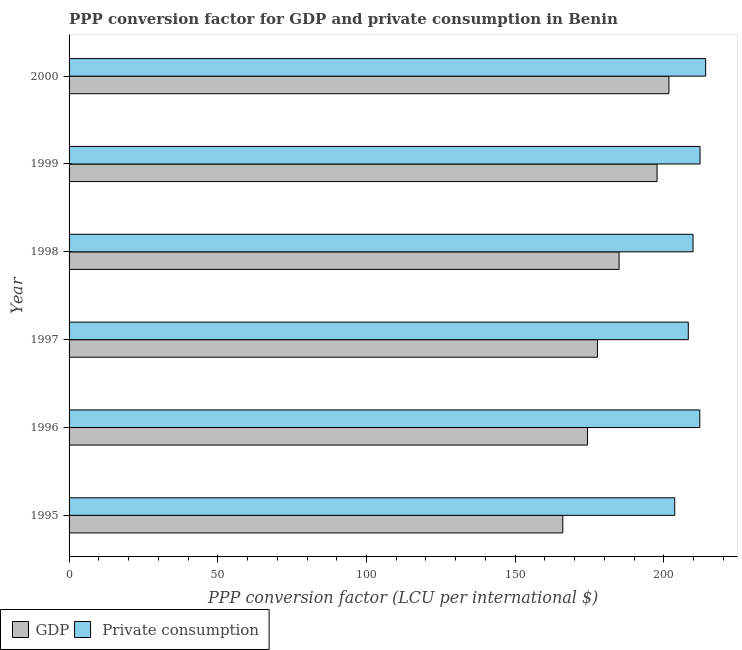How many different coloured bars are there?
Offer a very short reply. 2. Are the number of bars on each tick of the Y-axis equal?
Keep it short and to the point. Yes. How many bars are there on the 3rd tick from the top?
Give a very brief answer. 2. What is the ppp conversion factor for private consumption in 1995?
Provide a succinct answer. 203.64. Across all years, what is the maximum ppp conversion factor for private consumption?
Offer a terse response. 214.04. Across all years, what is the minimum ppp conversion factor for private consumption?
Provide a short and direct response. 203.64. In which year was the ppp conversion factor for gdp minimum?
Offer a terse response. 1995. What is the total ppp conversion factor for gdp in the graph?
Give a very brief answer. 1102.29. What is the difference between the ppp conversion factor for private consumption in 1999 and that in 2000?
Give a very brief answer. -1.89. What is the difference between the ppp conversion factor for private consumption in 1998 and the ppp conversion factor for gdp in 2000?
Offer a very short reply. 8.1. What is the average ppp conversion factor for gdp per year?
Your answer should be very brief. 183.72. In the year 1996, what is the difference between the ppp conversion factor for private consumption and ppp conversion factor for gdp?
Your answer should be very brief. 37.77. What is the ratio of the ppp conversion factor for gdp in 1997 to that in 1999?
Your answer should be compact. 0.9. Is the ppp conversion factor for gdp in 1996 less than that in 1998?
Make the answer very short. Yes. Is the difference between the ppp conversion factor for private consumption in 1997 and 2000 greater than the difference between the ppp conversion factor for gdp in 1997 and 2000?
Provide a short and direct response. Yes. What is the difference between the highest and the second highest ppp conversion factor for gdp?
Offer a terse response. 3.99. What is the difference between the highest and the lowest ppp conversion factor for gdp?
Make the answer very short. 35.68. In how many years, is the ppp conversion factor for gdp greater than the average ppp conversion factor for gdp taken over all years?
Provide a succinct answer. 3. Is the sum of the ppp conversion factor for gdp in 1995 and 1999 greater than the maximum ppp conversion factor for private consumption across all years?
Your answer should be compact. Yes. What does the 1st bar from the top in 1998 represents?
Offer a terse response.  Private consumption. What does the 2nd bar from the bottom in 1998 represents?
Provide a succinct answer.  Private consumption. How many bars are there?
Ensure brevity in your answer.  12. Are the values on the major ticks of X-axis written in scientific E-notation?
Your answer should be very brief. No. Does the graph contain grids?
Make the answer very short. No. Where does the legend appear in the graph?
Provide a short and direct response. Bottom left. What is the title of the graph?
Make the answer very short. PPP conversion factor for GDP and private consumption in Benin. What is the label or title of the X-axis?
Make the answer very short. PPP conversion factor (LCU per international $). What is the PPP conversion factor (LCU per international $) of GDP in 1995?
Offer a very short reply. 166.01. What is the PPP conversion factor (LCU per international $) in  Private consumption in 1995?
Your answer should be very brief. 203.64. What is the PPP conversion factor (LCU per international $) in GDP in 1996?
Your answer should be very brief. 174.29. What is the PPP conversion factor (LCU per international $) in  Private consumption in 1996?
Give a very brief answer. 212.07. What is the PPP conversion factor (LCU per international $) of GDP in 1997?
Your answer should be very brief. 177.65. What is the PPP conversion factor (LCU per international $) in  Private consumption in 1997?
Give a very brief answer. 208.2. What is the PPP conversion factor (LCU per international $) of GDP in 1998?
Your answer should be compact. 184.93. What is the PPP conversion factor (LCU per international $) of  Private consumption in 1998?
Keep it short and to the point. 209.79. What is the PPP conversion factor (LCU per international $) in GDP in 1999?
Make the answer very short. 197.71. What is the PPP conversion factor (LCU per international $) in  Private consumption in 1999?
Offer a very short reply. 212.16. What is the PPP conversion factor (LCU per international $) of GDP in 2000?
Give a very brief answer. 201.69. What is the PPP conversion factor (LCU per international $) in  Private consumption in 2000?
Your answer should be compact. 214.04. Across all years, what is the maximum PPP conversion factor (LCU per international $) in GDP?
Offer a very short reply. 201.69. Across all years, what is the maximum PPP conversion factor (LCU per international $) in  Private consumption?
Offer a terse response. 214.04. Across all years, what is the minimum PPP conversion factor (LCU per international $) of GDP?
Make the answer very short. 166.01. Across all years, what is the minimum PPP conversion factor (LCU per international $) of  Private consumption?
Offer a very short reply. 203.64. What is the total PPP conversion factor (LCU per international $) of GDP in the graph?
Offer a very short reply. 1102.29. What is the total PPP conversion factor (LCU per international $) of  Private consumption in the graph?
Ensure brevity in your answer.  1259.9. What is the difference between the PPP conversion factor (LCU per international $) of GDP in 1995 and that in 1996?
Ensure brevity in your answer.  -8.29. What is the difference between the PPP conversion factor (LCU per international $) of  Private consumption in 1995 and that in 1996?
Make the answer very short. -8.42. What is the difference between the PPP conversion factor (LCU per international $) of GDP in 1995 and that in 1997?
Provide a succinct answer. -11.64. What is the difference between the PPP conversion factor (LCU per international $) in  Private consumption in 1995 and that in 1997?
Make the answer very short. -4.56. What is the difference between the PPP conversion factor (LCU per international $) in GDP in 1995 and that in 1998?
Make the answer very short. -18.92. What is the difference between the PPP conversion factor (LCU per international $) in  Private consumption in 1995 and that in 1998?
Your answer should be very brief. -6.15. What is the difference between the PPP conversion factor (LCU per international $) in GDP in 1995 and that in 1999?
Your response must be concise. -31.7. What is the difference between the PPP conversion factor (LCU per international $) in  Private consumption in 1995 and that in 1999?
Offer a terse response. -8.51. What is the difference between the PPP conversion factor (LCU per international $) of GDP in 1995 and that in 2000?
Make the answer very short. -35.68. What is the difference between the PPP conversion factor (LCU per international $) in  Private consumption in 1995 and that in 2000?
Offer a terse response. -10.4. What is the difference between the PPP conversion factor (LCU per international $) of GDP in 1996 and that in 1997?
Ensure brevity in your answer.  -3.35. What is the difference between the PPP conversion factor (LCU per international $) of  Private consumption in 1996 and that in 1997?
Provide a succinct answer. 3.86. What is the difference between the PPP conversion factor (LCU per international $) of GDP in 1996 and that in 1998?
Provide a short and direct response. -10.64. What is the difference between the PPP conversion factor (LCU per international $) in  Private consumption in 1996 and that in 1998?
Your answer should be very brief. 2.27. What is the difference between the PPP conversion factor (LCU per international $) in GDP in 1996 and that in 1999?
Your answer should be compact. -23.41. What is the difference between the PPP conversion factor (LCU per international $) of  Private consumption in 1996 and that in 1999?
Your response must be concise. -0.09. What is the difference between the PPP conversion factor (LCU per international $) in GDP in 1996 and that in 2000?
Ensure brevity in your answer.  -27.4. What is the difference between the PPP conversion factor (LCU per international $) in  Private consumption in 1996 and that in 2000?
Make the answer very short. -1.97. What is the difference between the PPP conversion factor (LCU per international $) of GDP in 1997 and that in 1998?
Provide a succinct answer. -7.29. What is the difference between the PPP conversion factor (LCU per international $) of  Private consumption in 1997 and that in 1998?
Provide a short and direct response. -1.59. What is the difference between the PPP conversion factor (LCU per international $) of GDP in 1997 and that in 1999?
Ensure brevity in your answer.  -20.06. What is the difference between the PPP conversion factor (LCU per international $) of  Private consumption in 1997 and that in 1999?
Keep it short and to the point. -3.95. What is the difference between the PPP conversion factor (LCU per international $) of GDP in 1997 and that in 2000?
Your answer should be very brief. -24.05. What is the difference between the PPP conversion factor (LCU per international $) of  Private consumption in 1997 and that in 2000?
Keep it short and to the point. -5.84. What is the difference between the PPP conversion factor (LCU per international $) in GDP in 1998 and that in 1999?
Make the answer very short. -12.77. What is the difference between the PPP conversion factor (LCU per international $) of  Private consumption in 1998 and that in 1999?
Offer a very short reply. -2.36. What is the difference between the PPP conversion factor (LCU per international $) in GDP in 1998 and that in 2000?
Make the answer very short. -16.76. What is the difference between the PPP conversion factor (LCU per international $) in  Private consumption in 1998 and that in 2000?
Make the answer very short. -4.25. What is the difference between the PPP conversion factor (LCU per international $) in GDP in 1999 and that in 2000?
Provide a succinct answer. -3.99. What is the difference between the PPP conversion factor (LCU per international $) in  Private consumption in 1999 and that in 2000?
Keep it short and to the point. -1.89. What is the difference between the PPP conversion factor (LCU per international $) in GDP in 1995 and the PPP conversion factor (LCU per international $) in  Private consumption in 1996?
Your response must be concise. -46.06. What is the difference between the PPP conversion factor (LCU per international $) of GDP in 1995 and the PPP conversion factor (LCU per international $) of  Private consumption in 1997?
Provide a succinct answer. -42.19. What is the difference between the PPP conversion factor (LCU per international $) of GDP in 1995 and the PPP conversion factor (LCU per international $) of  Private consumption in 1998?
Give a very brief answer. -43.78. What is the difference between the PPP conversion factor (LCU per international $) in GDP in 1995 and the PPP conversion factor (LCU per international $) in  Private consumption in 1999?
Make the answer very short. -46.15. What is the difference between the PPP conversion factor (LCU per international $) of GDP in 1995 and the PPP conversion factor (LCU per international $) of  Private consumption in 2000?
Provide a short and direct response. -48.03. What is the difference between the PPP conversion factor (LCU per international $) of GDP in 1996 and the PPP conversion factor (LCU per international $) of  Private consumption in 1997?
Your answer should be compact. -33.91. What is the difference between the PPP conversion factor (LCU per international $) of GDP in 1996 and the PPP conversion factor (LCU per international $) of  Private consumption in 1998?
Offer a terse response. -35.5. What is the difference between the PPP conversion factor (LCU per international $) in GDP in 1996 and the PPP conversion factor (LCU per international $) in  Private consumption in 1999?
Provide a short and direct response. -37.86. What is the difference between the PPP conversion factor (LCU per international $) of GDP in 1996 and the PPP conversion factor (LCU per international $) of  Private consumption in 2000?
Your answer should be very brief. -39.75. What is the difference between the PPP conversion factor (LCU per international $) in GDP in 1997 and the PPP conversion factor (LCU per international $) in  Private consumption in 1998?
Provide a short and direct response. -32.15. What is the difference between the PPP conversion factor (LCU per international $) in GDP in 1997 and the PPP conversion factor (LCU per international $) in  Private consumption in 1999?
Your response must be concise. -34.51. What is the difference between the PPP conversion factor (LCU per international $) of GDP in 1997 and the PPP conversion factor (LCU per international $) of  Private consumption in 2000?
Provide a short and direct response. -36.39. What is the difference between the PPP conversion factor (LCU per international $) of GDP in 1998 and the PPP conversion factor (LCU per international $) of  Private consumption in 1999?
Your answer should be very brief. -27.22. What is the difference between the PPP conversion factor (LCU per international $) in GDP in 1998 and the PPP conversion factor (LCU per international $) in  Private consumption in 2000?
Ensure brevity in your answer.  -29.11. What is the difference between the PPP conversion factor (LCU per international $) in GDP in 1999 and the PPP conversion factor (LCU per international $) in  Private consumption in 2000?
Provide a short and direct response. -16.33. What is the average PPP conversion factor (LCU per international $) in GDP per year?
Your answer should be very brief. 183.71. What is the average PPP conversion factor (LCU per international $) of  Private consumption per year?
Offer a very short reply. 209.98. In the year 1995, what is the difference between the PPP conversion factor (LCU per international $) of GDP and PPP conversion factor (LCU per international $) of  Private consumption?
Offer a very short reply. -37.63. In the year 1996, what is the difference between the PPP conversion factor (LCU per international $) of GDP and PPP conversion factor (LCU per international $) of  Private consumption?
Make the answer very short. -37.77. In the year 1997, what is the difference between the PPP conversion factor (LCU per international $) of GDP and PPP conversion factor (LCU per international $) of  Private consumption?
Give a very brief answer. -30.56. In the year 1998, what is the difference between the PPP conversion factor (LCU per international $) of GDP and PPP conversion factor (LCU per international $) of  Private consumption?
Ensure brevity in your answer.  -24.86. In the year 1999, what is the difference between the PPP conversion factor (LCU per international $) of GDP and PPP conversion factor (LCU per international $) of  Private consumption?
Provide a short and direct response. -14.45. In the year 2000, what is the difference between the PPP conversion factor (LCU per international $) of GDP and PPP conversion factor (LCU per international $) of  Private consumption?
Your response must be concise. -12.35. What is the ratio of the PPP conversion factor (LCU per international $) of GDP in 1995 to that in 1996?
Keep it short and to the point. 0.95. What is the ratio of the PPP conversion factor (LCU per international $) of  Private consumption in 1995 to that in 1996?
Offer a terse response. 0.96. What is the ratio of the PPP conversion factor (LCU per international $) of GDP in 1995 to that in 1997?
Your answer should be compact. 0.93. What is the ratio of the PPP conversion factor (LCU per international $) of  Private consumption in 1995 to that in 1997?
Your answer should be very brief. 0.98. What is the ratio of the PPP conversion factor (LCU per international $) of GDP in 1995 to that in 1998?
Give a very brief answer. 0.9. What is the ratio of the PPP conversion factor (LCU per international $) in  Private consumption in 1995 to that in 1998?
Keep it short and to the point. 0.97. What is the ratio of the PPP conversion factor (LCU per international $) of GDP in 1995 to that in 1999?
Offer a terse response. 0.84. What is the ratio of the PPP conversion factor (LCU per international $) in  Private consumption in 1995 to that in 1999?
Give a very brief answer. 0.96. What is the ratio of the PPP conversion factor (LCU per international $) in GDP in 1995 to that in 2000?
Provide a succinct answer. 0.82. What is the ratio of the PPP conversion factor (LCU per international $) of  Private consumption in 1995 to that in 2000?
Offer a very short reply. 0.95. What is the ratio of the PPP conversion factor (LCU per international $) in GDP in 1996 to that in 1997?
Make the answer very short. 0.98. What is the ratio of the PPP conversion factor (LCU per international $) in  Private consumption in 1996 to that in 1997?
Your answer should be compact. 1.02. What is the ratio of the PPP conversion factor (LCU per international $) in GDP in 1996 to that in 1998?
Offer a terse response. 0.94. What is the ratio of the PPP conversion factor (LCU per international $) in  Private consumption in 1996 to that in 1998?
Your response must be concise. 1.01. What is the ratio of the PPP conversion factor (LCU per international $) in GDP in 1996 to that in 1999?
Keep it short and to the point. 0.88. What is the ratio of the PPP conversion factor (LCU per international $) in  Private consumption in 1996 to that in 1999?
Your response must be concise. 1. What is the ratio of the PPP conversion factor (LCU per international $) of GDP in 1996 to that in 2000?
Give a very brief answer. 0.86. What is the ratio of the PPP conversion factor (LCU per international $) in GDP in 1997 to that in 1998?
Provide a succinct answer. 0.96. What is the ratio of the PPP conversion factor (LCU per international $) in GDP in 1997 to that in 1999?
Provide a succinct answer. 0.9. What is the ratio of the PPP conversion factor (LCU per international $) in  Private consumption in 1997 to that in 1999?
Offer a terse response. 0.98. What is the ratio of the PPP conversion factor (LCU per international $) of GDP in 1997 to that in 2000?
Your answer should be compact. 0.88. What is the ratio of the PPP conversion factor (LCU per international $) of  Private consumption in 1997 to that in 2000?
Offer a terse response. 0.97. What is the ratio of the PPP conversion factor (LCU per international $) of GDP in 1998 to that in 1999?
Offer a terse response. 0.94. What is the ratio of the PPP conversion factor (LCU per international $) in  Private consumption in 1998 to that in 1999?
Your answer should be very brief. 0.99. What is the ratio of the PPP conversion factor (LCU per international $) in GDP in 1998 to that in 2000?
Offer a terse response. 0.92. What is the ratio of the PPP conversion factor (LCU per international $) in  Private consumption in 1998 to that in 2000?
Offer a very short reply. 0.98. What is the ratio of the PPP conversion factor (LCU per international $) of GDP in 1999 to that in 2000?
Provide a succinct answer. 0.98. What is the ratio of the PPP conversion factor (LCU per international $) of  Private consumption in 1999 to that in 2000?
Provide a succinct answer. 0.99. What is the difference between the highest and the second highest PPP conversion factor (LCU per international $) of GDP?
Your answer should be compact. 3.99. What is the difference between the highest and the second highest PPP conversion factor (LCU per international $) in  Private consumption?
Give a very brief answer. 1.89. What is the difference between the highest and the lowest PPP conversion factor (LCU per international $) in GDP?
Give a very brief answer. 35.68. What is the difference between the highest and the lowest PPP conversion factor (LCU per international $) of  Private consumption?
Provide a short and direct response. 10.4. 